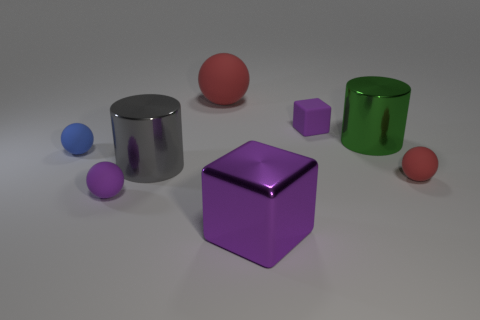Add 1 rubber things. How many objects exist? 9 Subtract all cylinders. How many objects are left? 6 Add 1 green shiny cylinders. How many green shiny cylinders are left? 2 Add 5 purple shiny objects. How many purple shiny objects exist? 6 Subtract 1 blue balls. How many objects are left? 7 Subtract all blue matte things. Subtract all large gray cylinders. How many objects are left? 6 